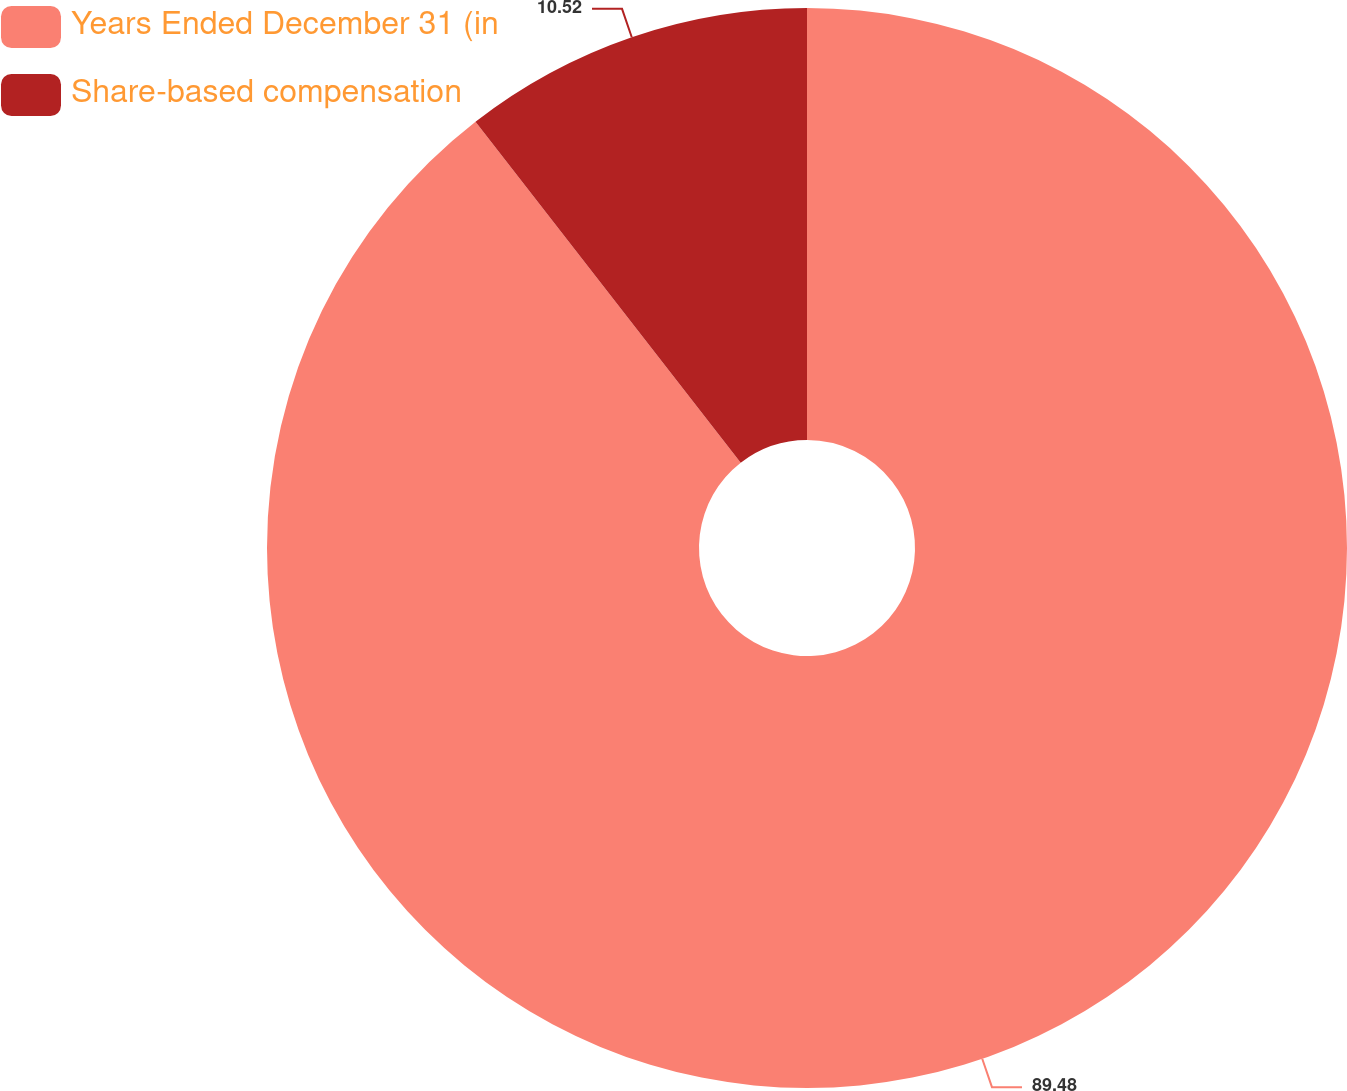Convert chart. <chart><loc_0><loc_0><loc_500><loc_500><pie_chart><fcel>Years Ended December 31 (in<fcel>Share-based compensation<nl><fcel>89.48%<fcel>10.52%<nl></chart> 